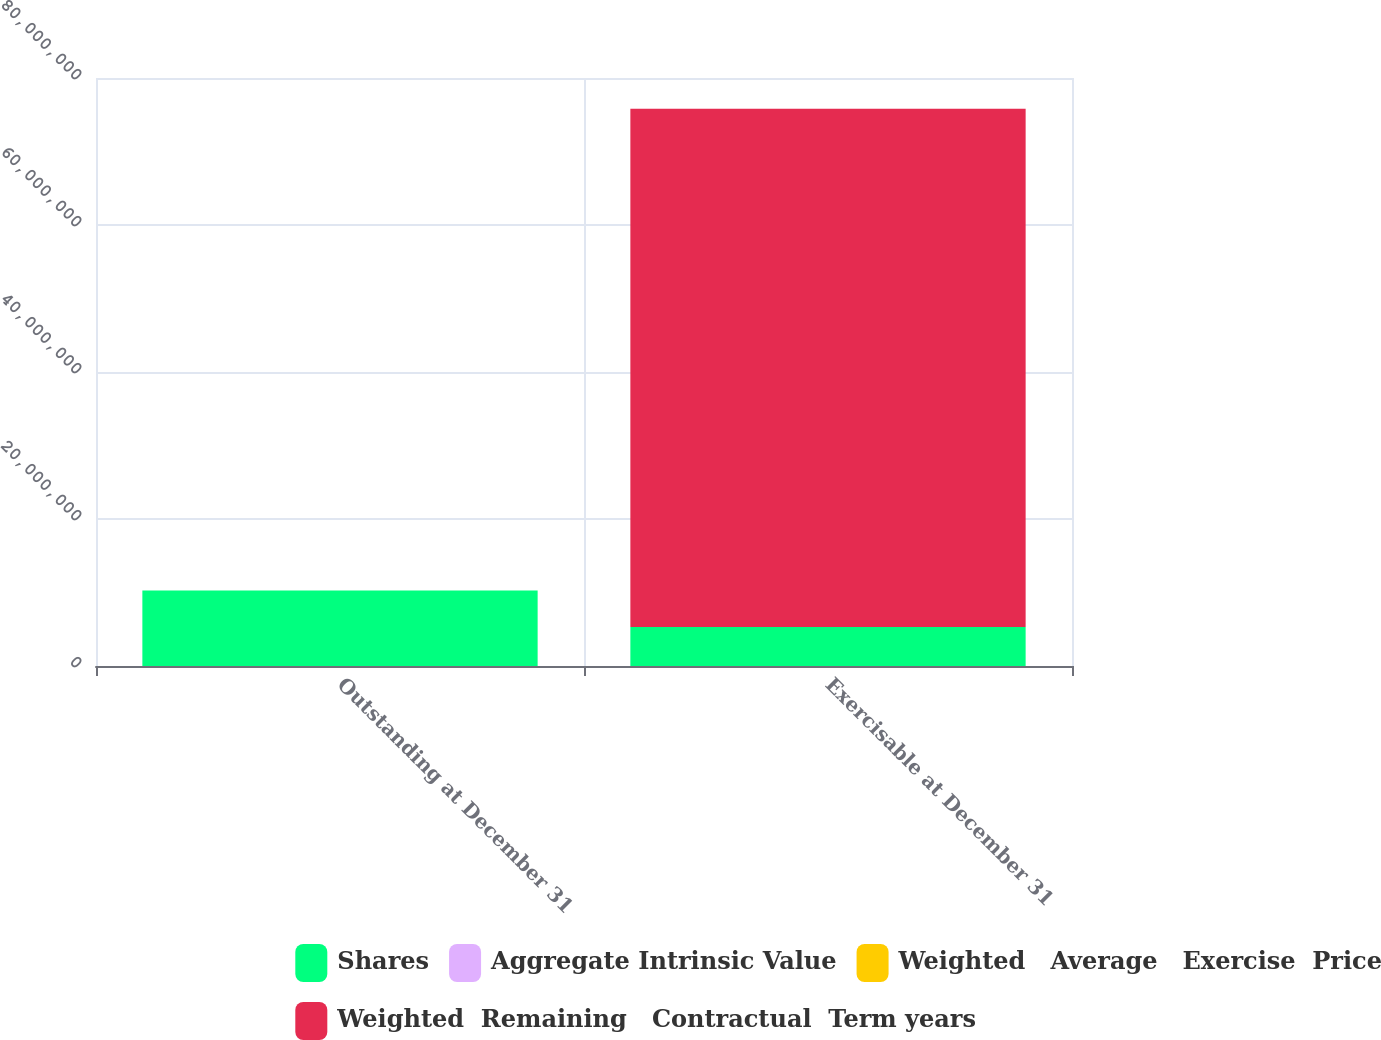Convert chart to OTSL. <chart><loc_0><loc_0><loc_500><loc_500><stacked_bar_chart><ecel><fcel>Outstanding at December 31<fcel>Exercisable at December 31<nl><fcel>Shares<fcel>1.0256e+07<fcel>5.30846e+06<nl><fcel>Aggregate Intrinsic Value<fcel>34.19<fcel>33.14<nl><fcel>Weighted   Average   Exercise  Price<fcel>7.3<fcel>6.05<nl><fcel>Weighted  Remaining   Contractual  Term years<fcel>34.19<fcel>7.04994e+07<nl></chart> 